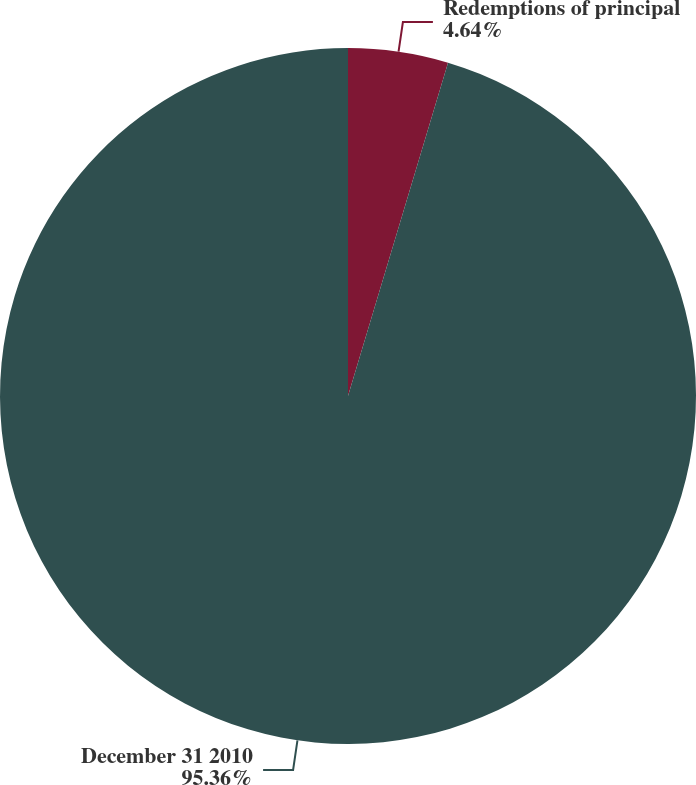Convert chart to OTSL. <chart><loc_0><loc_0><loc_500><loc_500><pie_chart><fcel>Redemptions of principal<fcel>December 31 2010<nl><fcel>4.64%<fcel>95.36%<nl></chart> 